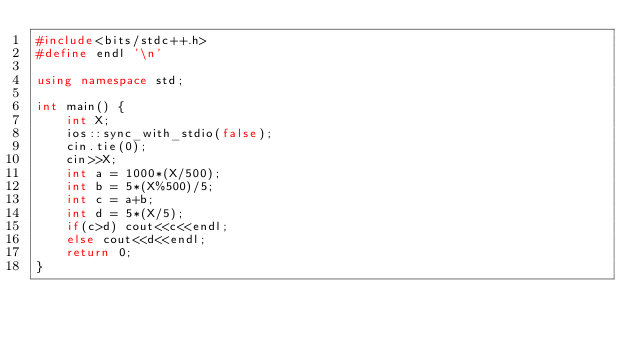Convert code to text. <code><loc_0><loc_0><loc_500><loc_500><_C++_>#include<bits/stdc++.h>
#define endl '\n'

using namespace std;

int main() {
    int X;
    ios::sync_with_stdio(false);
    cin.tie(0);
    cin>>X;
    int a = 1000*(X/500);
    int b = 5*(X%500)/5;
    int c = a+b;
    int d = 5*(X/5);
    if(c>d) cout<<c<<endl;
    else cout<<d<<endl;
    return 0;
}

</code> 